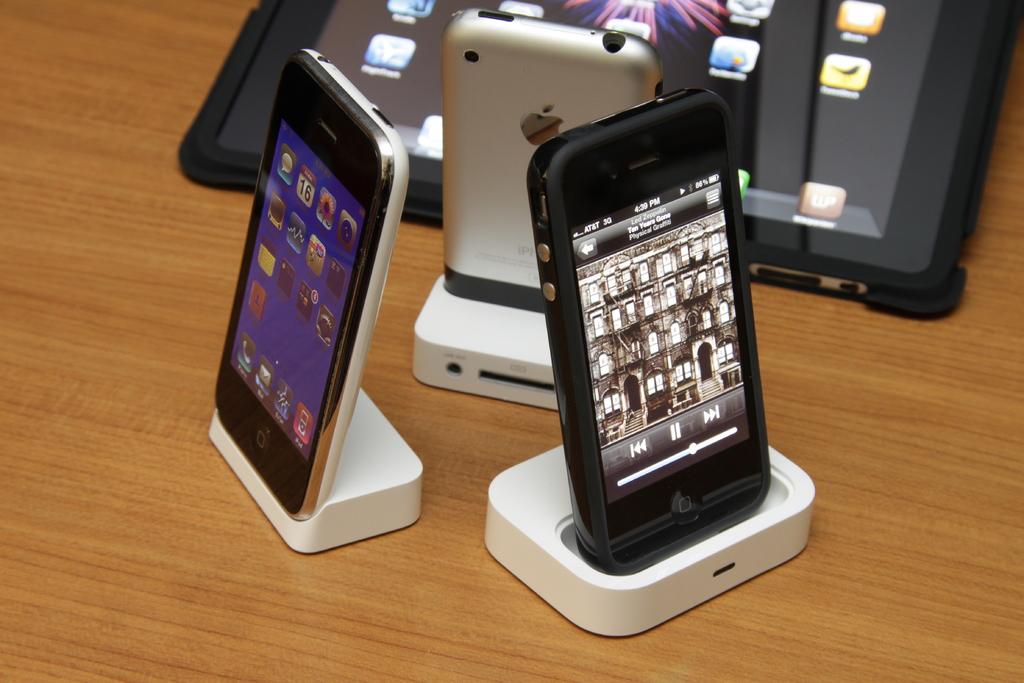What day of the month is it, according to the phone?
Your answer should be very brief. 16. 